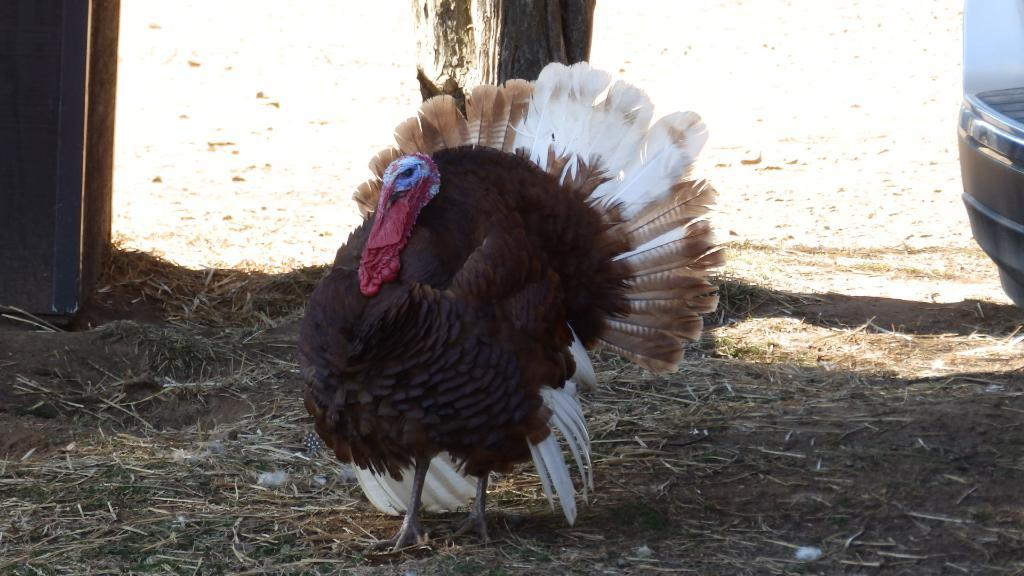What type of animal is in the image? There is a bird in the image. Where is the bird located in the image? The bird is standing on the ground. What can be seen in the background of the image? There is a tree in the background of the image. Are there any other objects visible on the ground in the background? Yes, there are other objects on the ground in the background of the image. Can you see the moon in the image? No, the moon is not present in the image. What is an example of a frame that could be used to display this image? The provided facts do not give information about the frame or how the image is displayed, so it is impossible to provide an example. 